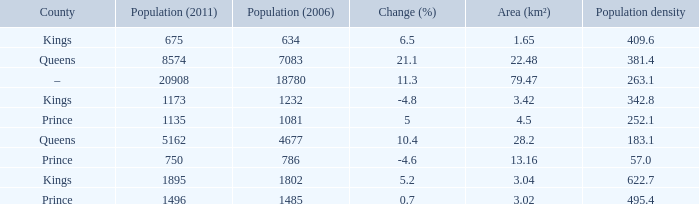In the County of Prince, what was the highest Population density when the Area (km²) was larger than 3.02, and the Population (2006) was larger than 786, and the Population (2011) was smaller than 1135? None. 